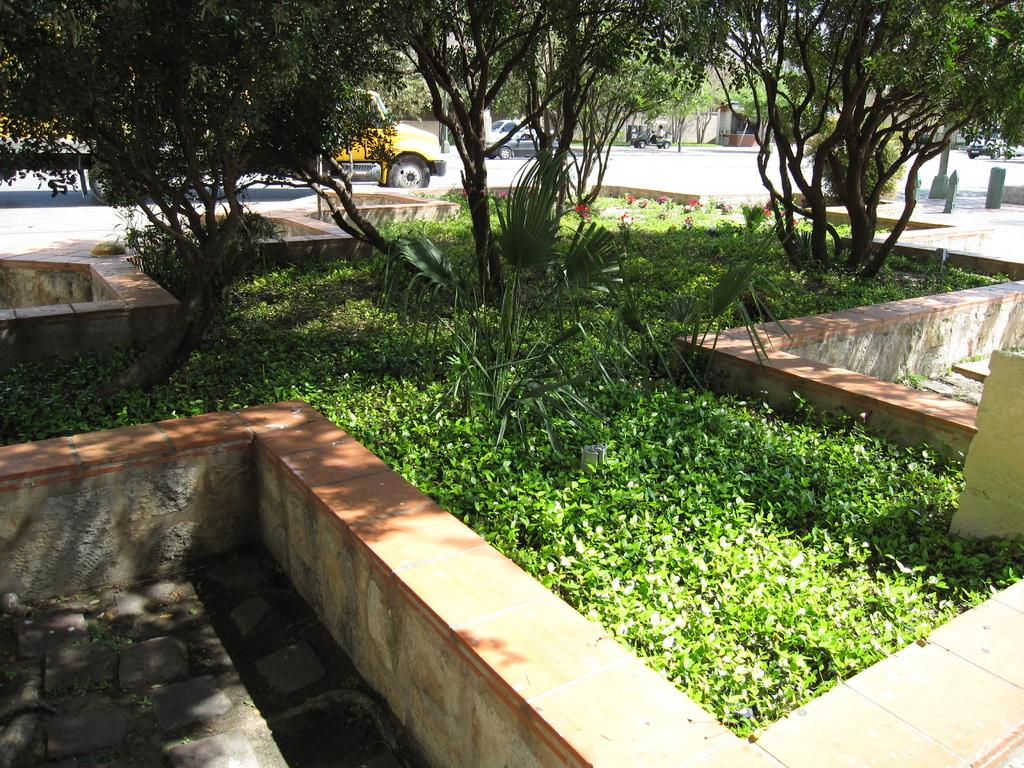What type of vegetation can be seen in the image? There is grass, plants, and trees in the image. What else is present in the image besides vegetation? There are vehicles in the image. What type of stamp can be seen on the underwear in the image? There is no underwear or stamp present in the image. 